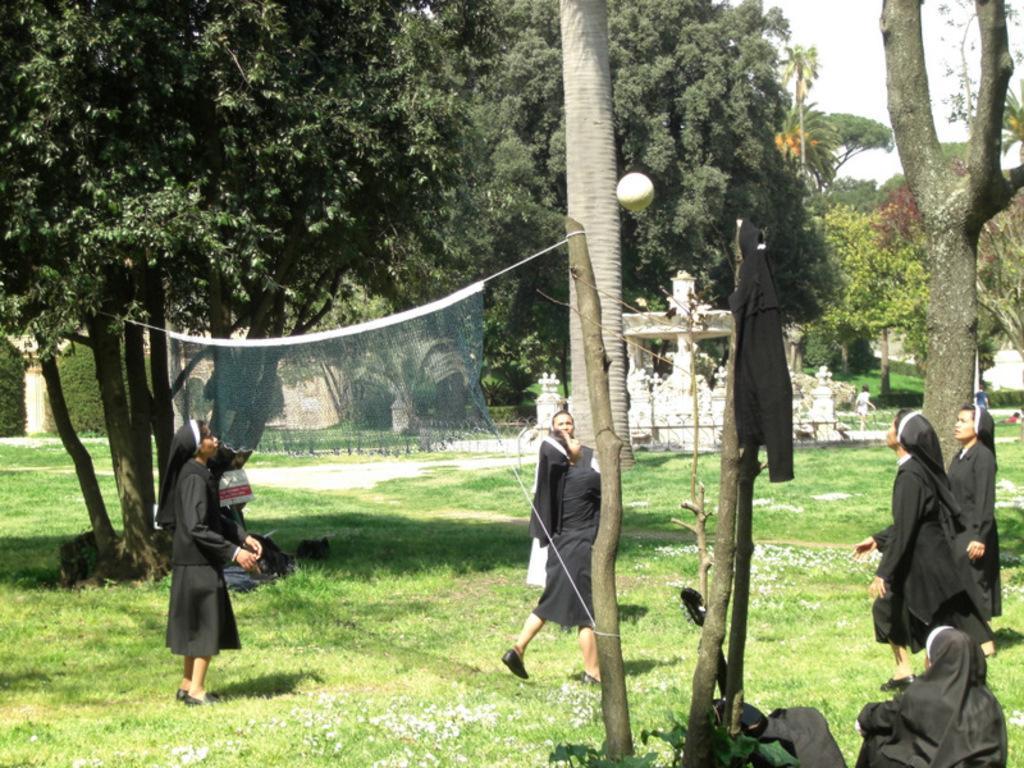Describe this image in one or two sentences. In this image we can see girls playing volleyball. There are trees. At the bottom of the image there is grass. There is net. 